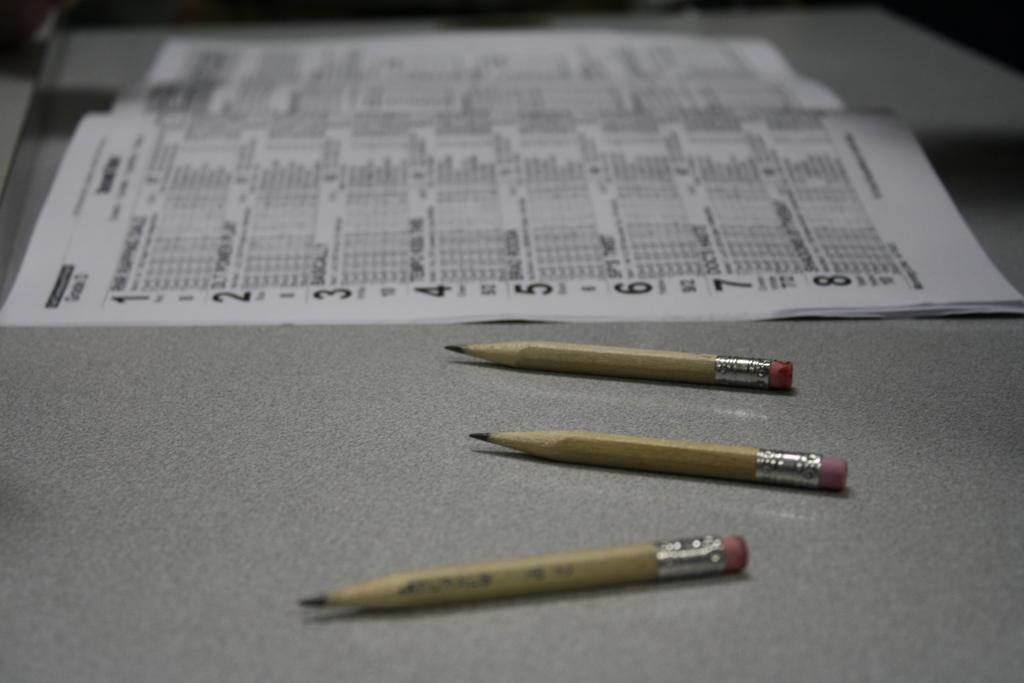What objects are present in the image? There are three brown pencils in the image. Where are the pencils located? The pencils are placed on a grey table top. What else can be seen on the table top? There is a calendar paper on the table top. What type of toothpaste is shown in the image? There is no toothpaste present in the image. How many circles can be seen on the calendar paper? The provided facts do not mention any circles on the calendar paper, so we cannot determine the number of circles from the image. 